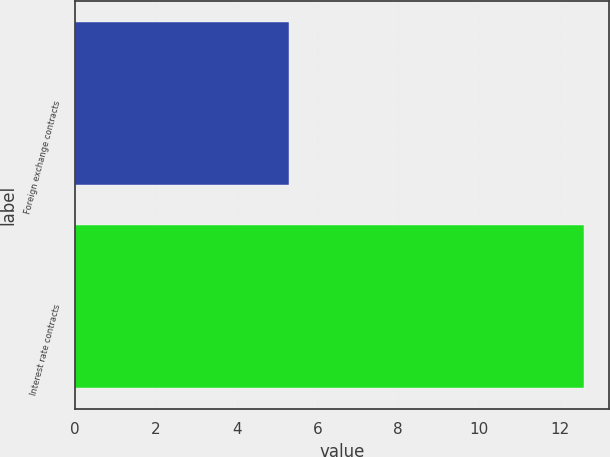<chart> <loc_0><loc_0><loc_500><loc_500><bar_chart><fcel>Foreign exchange contracts<fcel>Interest rate contracts<nl><fcel>5.3<fcel>12.6<nl></chart> 